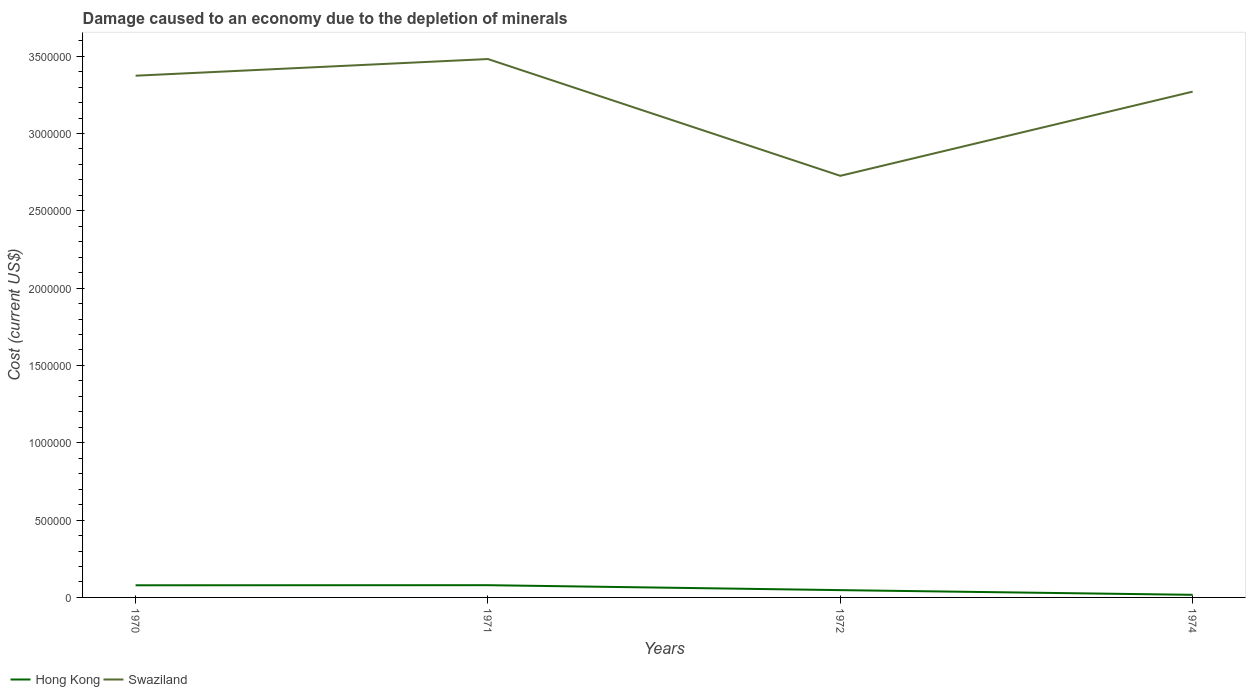Across all years, what is the maximum cost of damage caused due to the depletion of minerals in Hong Kong?
Provide a succinct answer. 1.68e+04. In which year was the cost of damage caused due to the depletion of minerals in Swaziland maximum?
Your answer should be compact. 1972. What is the total cost of damage caused due to the depletion of minerals in Swaziland in the graph?
Keep it short and to the point. -1.08e+05. What is the difference between the highest and the second highest cost of damage caused due to the depletion of minerals in Hong Kong?
Keep it short and to the point. 6.23e+04. What is the difference between the highest and the lowest cost of damage caused due to the depletion of minerals in Hong Kong?
Your response must be concise. 2. What is the difference between two consecutive major ticks on the Y-axis?
Provide a short and direct response. 5.00e+05. Are the values on the major ticks of Y-axis written in scientific E-notation?
Make the answer very short. No. Where does the legend appear in the graph?
Ensure brevity in your answer.  Bottom left. How many legend labels are there?
Provide a succinct answer. 2. How are the legend labels stacked?
Keep it short and to the point. Horizontal. What is the title of the graph?
Provide a short and direct response. Damage caused to an economy due to the depletion of minerals. Does "Estonia" appear as one of the legend labels in the graph?
Your response must be concise. No. What is the label or title of the X-axis?
Make the answer very short. Years. What is the label or title of the Y-axis?
Provide a succinct answer. Cost (current US$). What is the Cost (current US$) of Hong Kong in 1970?
Provide a short and direct response. 7.85e+04. What is the Cost (current US$) in Swaziland in 1970?
Your response must be concise. 3.37e+06. What is the Cost (current US$) in Hong Kong in 1971?
Your response must be concise. 7.92e+04. What is the Cost (current US$) in Swaziland in 1971?
Ensure brevity in your answer.  3.48e+06. What is the Cost (current US$) in Hong Kong in 1972?
Provide a succinct answer. 4.73e+04. What is the Cost (current US$) of Swaziland in 1972?
Ensure brevity in your answer.  2.73e+06. What is the Cost (current US$) of Hong Kong in 1974?
Your answer should be very brief. 1.68e+04. What is the Cost (current US$) of Swaziland in 1974?
Keep it short and to the point. 3.27e+06. Across all years, what is the maximum Cost (current US$) of Hong Kong?
Your answer should be compact. 7.92e+04. Across all years, what is the maximum Cost (current US$) of Swaziland?
Your answer should be compact. 3.48e+06. Across all years, what is the minimum Cost (current US$) in Hong Kong?
Your answer should be compact. 1.68e+04. Across all years, what is the minimum Cost (current US$) in Swaziland?
Offer a terse response. 2.73e+06. What is the total Cost (current US$) in Hong Kong in the graph?
Provide a short and direct response. 2.22e+05. What is the total Cost (current US$) in Swaziland in the graph?
Ensure brevity in your answer.  1.29e+07. What is the difference between the Cost (current US$) of Hong Kong in 1970 and that in 1971?
Your response must be concise. -683.34. What is the difference between the Cost (current US$) in Swaziland in 1970 and that in 1971?
Keep it short and to the point. -1.08e+05. What is the difference between the Cost (current US$) in Hong Kong in 1970 and that in 1972?
Offer a terse response. 3.12e+04. What is the difference between the Cost (current US$) in Swaziland in 1970 and that in 1972?
Provide a succinct answer. 6.47e+05. What is the difference between the Cost (current US$) in Hong Kong in 1970 and that in 1974?
Your answer should be very brief. 6.16e+04. What is the difference between the Cost (current US$) in Swaziland in 1970 and that in 1974?
Your answer should be very brief. 1.03e+05. What is the difference between the Cost (current US$) in Hong Kong in 1971 and that in 1972?
Your response must be concise. 3.19e+04. What is the difference between the Cost (current US$) of Swaziland in 1971 and that in 1972?
Your response must be concise. 7.55e+05. What is the difference between the Cost (current US$) in Hong Kong in 1971 and that in 1974?
Ensure brevity in your answer.  6.23e+04. What is the difference between the Cost (current US$) in Swaziland in 1971 and that in 1974?
Your answer should be compact. 2.11e+05. What is the difference between the Cost (current US$) in Hong Kong in 1972 and that in 1974?
Your answer should be compact. 3.04e+04. What is the difference between the Cost (current US$) of Swaziland in 1972 and that in 1974?
Offer a terse response. -5.44e+05. What is the difference between the Cost (current US$) of Hong Kong in 1970 and the Cost (current US$) of Swaziland in 1971?
Your answer should be compact. -3.40e+06. What is the difference between the Cost (current US$) of Hong Kong in 1970 and the Cost (current US$) of Swaziland in 1972?
Your response must be concise. -2.65e+06. What is the difference between the Cost (current US$) in Hong Kong in 1970 and the Cost (current US$) in Swaziland in 1974?
Provide a succinct answer. -3.19e+06. What is the difference between the Cost (current US$) of Hong Kong in 1971 and the Cost (current US$) of Swaziland in 1972?
Your answer should be compact. -2.65e+06. What is the difference between the Cost (current US$) in Hong Kong in 1971 and the Cost (current US$) in Swaziland in 1974?
Offer a very short reply. -3.19e+06. What is the difference between the Cost (current US$) in Hong Kong in 1972 and the Cost (current US$) in Swaziland in 1974?
Provide a succinct answer. -3.22e+06. What is the average Cost (current US$) of Hong Kong per year?
Provide a short and direct response. 5.54e+04. What is the average Cost (current US$) in Swaziland per year?
Your answer should be very brief. 3.21e+06. In the year 1970, what is the difference between the Cost (current US$) in Hong Kong and Cost (current US$) in Swaziland?
Make the answer very short. -3.30e+06. In the year 1971, what is the difference between the Cost (current US$) in Hong Kong and Cost (current US$) in Swaziland?
Your response must be concise. -3.40e+06. In the year 1972, what is the difference between the Cost (current US$) in Hong Kong and Cost (current US$) in Swaziland?
Ensure brevity in your answer.  -2.68e+06. In the year 1974, what is the difference between the Cost (current US$) of Hong Kong and Cost (current US$) of Swaziland?
Offer a terse response. -3.25e+06. What is the ratio of the Cost (current US$) in Hong Kong in 1970 to that in 1971?
Your answer should be very brief. 0.99. What is the ratio of the Cost (current US$) in Hong Kong in 1970 to that in 1972?
Your response must be concise. 1.66. What is the ratio of the Cost (current US$) in Swaziland in 1970 to that in 1972?
Provide a short and direct response. 1.24. What is the ratio of the Cost (current US$) of Hong Kong in 1970 to that in 1974?
Ensure brevity in your answer.  4.66. What is the ratio of the Cost (current US$) of Swaziland in 1970 to that in 1974?
Make the answer very short. 1.03. What is the ratio of the Cost (current US$) in Hong Kong in 1971 to that in 1972?
Your answer should be very brief. 1.68. What is the ratio of the Cost (current US$) in Swaziland in 1971 to that in 1972?
Provide a short and direct response. 1.28. What is the ratio of the Cost (current US$) of Hong Kong in 1971 to that in 1974?
Offer a very short reply. 4.7. What is the ratio of the Cost (current US$) in Swaziland in 1971 to that in 1974?
Ensure brevity in your answer.  1.06. What is the ratio of the Cost (current US$) of Hong Kong in 1972 to that in 1974?
Keep it short and to the point. 2.81. What is the ratio of the Cost (current US$) of Swaziland in 1972 to that in 1974?
Your answer should be very brief. 0.83. What is the difference between the highest and the second highest Cost (current US$) of Hong Kong?
Ensure brevity in your answer.  683.34. What is the difference between the highest and the second highest Cost (current US$) in Swaziland?
Give a very brief answer. 1.08e+05. What is the difference between the highest and the lowest Cost (current US$) in Hong Kong?
Offer a very short reply. 6.23e+04. What is the difference between the highest and the lowest Cost (current US$) in Swaziland?
Offer a terse response. 7.55e+05. 